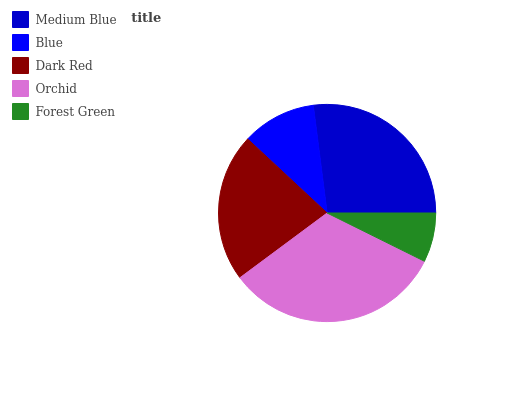Is Forest Green the minimum?
Answer yes or no. Yes. Is Orchid the maximum?
Answer yes or no. Yes. Is Blue the minimum?
Answer yes or no. No. Is Blue the maximum?
Answer yes or no. No. Is Medium Blue greater than Blue?
Answer yes or no. Yes. Is Blue less than Medium Blue?
Answer yes or no. Yes. Is Blue greater than Medium Blue?
Answer yes or no. No. Is Medium Blue less than Blue?
Answer yes or no. No. Is Dark Red the high median?
Answer yes or no. Yes. Is Dark Red the low median?
Answer yes or no. Yes. Is Forest Green the high median?
Answer yes or no. No. Is Blue the low median?
Answer yes or no. No. 